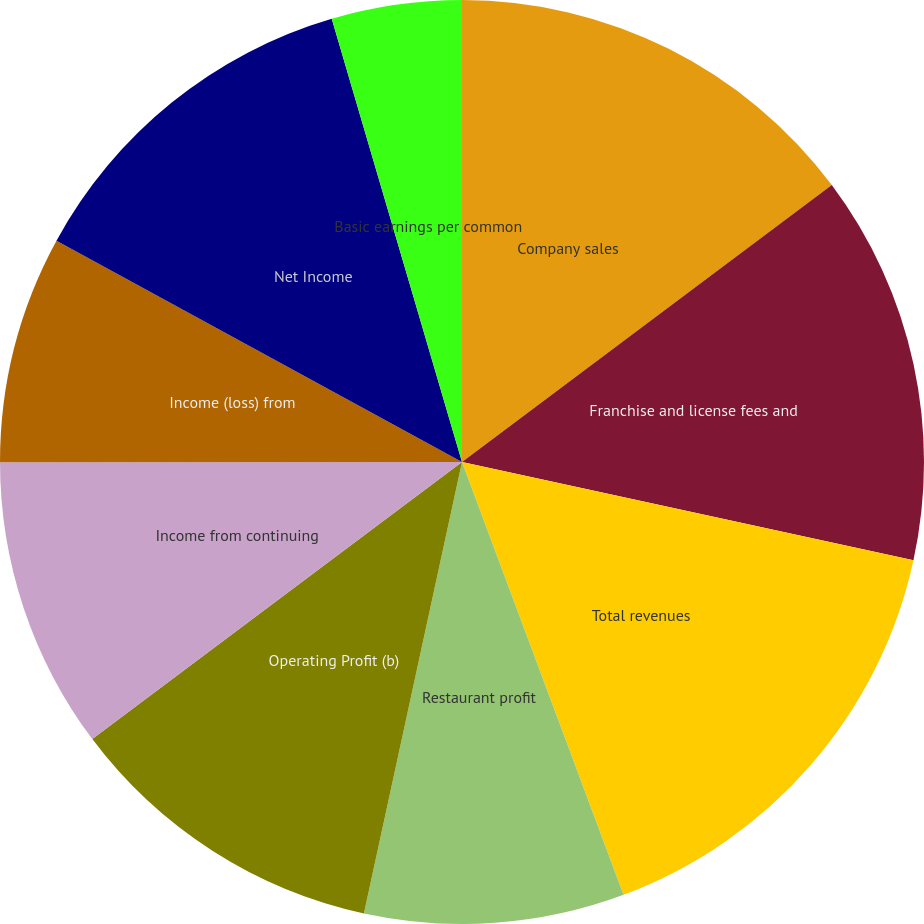Convert chart to OTSL. <chart><loc_0><loc_0><loc_500><loc_500><pie_chart><fcel>Company sales<fcel>Franchise and license fees and<fcel>Total revenues<fcel>Restaurant profit<fcel>Operating Profit (b)<fcel>Income from continuing<fcel>Income (loss) from<fcel>Net Income<fcel>Basic earnings per common<fcel>Basic earnings (loss) per<nl><fcel>14.77%<fcel>13.64%<fcel>15.91%<fcel>9.09%<fcel>11.36%<fcel>10.23%<fcel>7.96%<fcel>12.5%<fcel>4.55%<fcel>0.0%<nl></chart> 